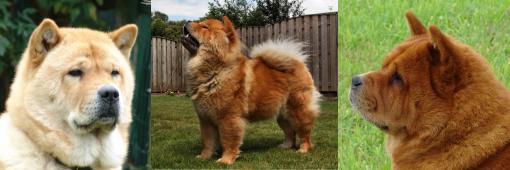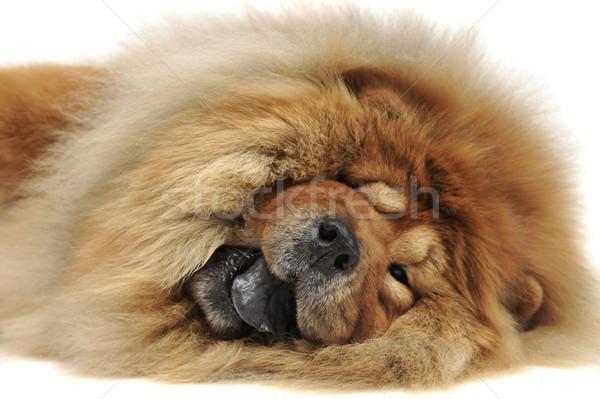The first image is the image on the left, the second image is the image on the right. Examine the images to the left and right. Is the description "There are two dogs in the right image." accurate? Answer yes or no. No. The first image is the image on the left, the second image is the image on the right. Examine the images to the left and right. Is the description "Each image contains the same number of dogs, the left image includes a dog with its blue tongue out, and at least one image features a dog in a standing pose." accurate? Answer yes or no. No. 